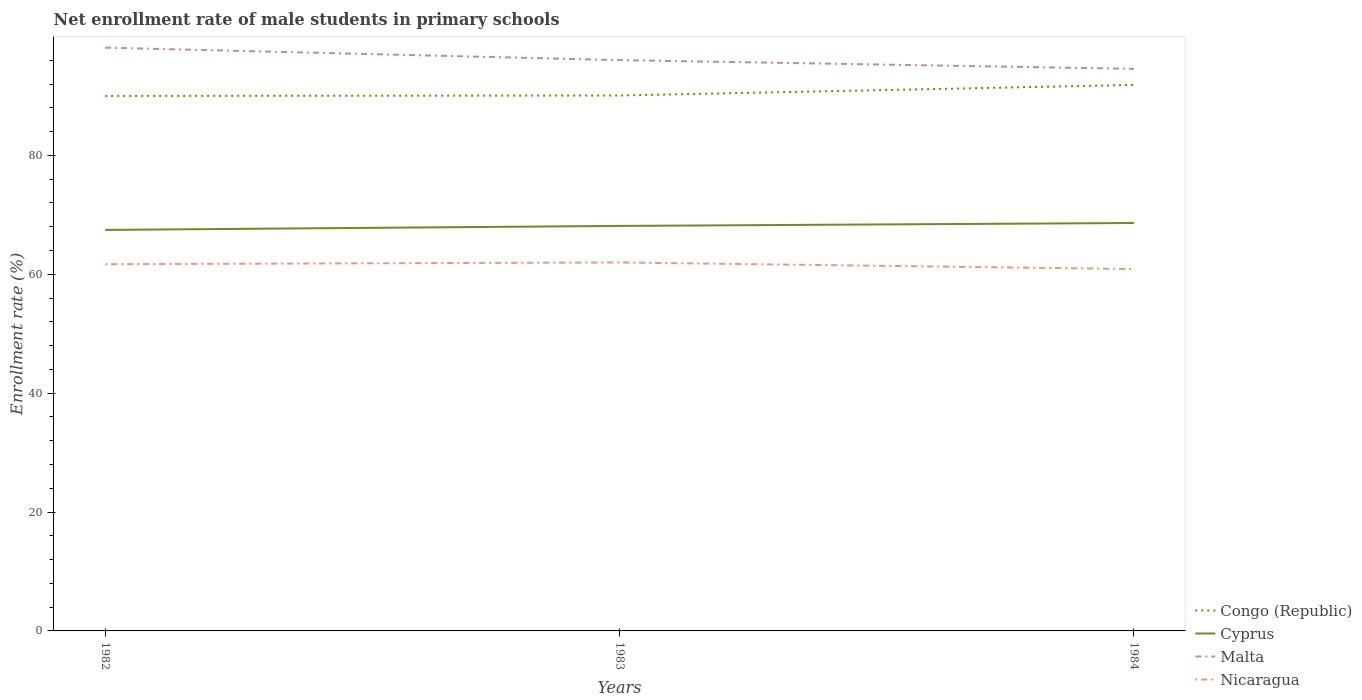How many different coloured lines are there?
Offer a very short reply. 4. Does the line corresponding to Nicaragua intersect with the line corresponding to Cyprus?
Keep it short and to the point. No. Is the number of lines equal to the number of legend labels?
Offer a very short reply. Yes. Across all years, what is the maximum net enrollment rate of male students in primary schools in Congo (Republic)?
Your answer should be compact. 90. What is the total net enrollment rate of male students in primary schools in Nicaragua in the graph?
Offer a terse response. -0.29. What is the difference between the highest and the second highest net enrollment rate of male students in primary schools in Cyprus?
Provide a short and direct response. 1.16. What is the difference between the highest and the lowest net enrollment rate of male students in primary schools in Congo (Republic)?
Keep it short and to the point. 1. How many years are there in the graph?
Make the answer very short. 3. Does the graph contain any zero values?
Your answer should be compact. No. Where does the legend appear in the graph?
Provide a succinct answer. Bottom right. How many legend labels are there?
Provide a succinct answer. 4. What is the title of the graph?
Your answer should be very brief. Net enrollment rate of male students in primary schools. Does "Comoros" appear as one of the legend labels in the graph?
Give a very brief answer. No. What is the label or title of the X-axis?
Ensure brevity in your answer.  Years. What is the label or title of the Y-axis?
Offer a very short reply. Enrollment rate (%). What is the Enrollment rate (%) in Congo (Republic) in 1982?
Your answer should be very brief. 90. What is the Enrollment rate (%) of Cyprus in 1982?
Provide a succinct answer. 67.47. What is the Enrollment rate (%) in Malta in 1982?
Ensure brevity in your answer.  98.13. What is the Enrollment rate (%) in Nicaragua in 1982?
Make the answer very short. 61.7. What is the Enrollment rate (%) in Congo (Republic) in 1983?
Offer a terse response. 90.08. What is the Enrollment rate (%) in Cyprus in 1983?
Offer a terse response. 68.14. What is the Enrollment rate (%) in Malta in 1983?
Make the answer very short. 96.04. What is the Enrollment rate (%) of Nicaragua in 1983?
Keep it short and to the point. 61.99. What is the Enrollment rate (%) of Congo (Republic) in 1984?
Provide a succinct answer. 91.86. What is the Enrollment rate (%) of Cyprus in 1984?
Provide a short and direct response. 68.63. What is the Enrollment rate (%) in Malta in 1984?
Offer a very short reply. 94.57. What is the Enrollment rate (%) of Nicaragua in 1984?
Ensure brevity in your answer.  60.88. Across all years, what is the maximum Enrollment rate (%) in Congo (Republic)?
Keep it short and to the point. 91.86. Across all years, what is the maximum Enrollment rate (%) in Cyprus?
Provide a short and direct response. 68.63. Across all years, what is the maximum Enrollment rate (%) in Malta?
Make the answer very short. 98.13. Across all years, what is the maximum Enrollment rate (%) of Nicaragua?
Provide a succinct answer. 61.99. Across all years, what is the minimum Enrollment rate (%) of Congo (Republic)?
Give a very brief answer. 90. Across all years, what is the minimum Enrollment rate (%) of Cyprus?
Your response must be concise. 67.47. Across all years, what is the minimum Enrollment rate (%) of Malta?
Your answer should be compact. 94.57. Across all years, what is the minimum Enrollment rate (%) of Nicaragua?
Make the answer very short. 60.88. What is the total Enrollment rate (%) of Congo (Republic) in the graph?
Your response must be concise. 271.95. What is the total Enrollment rate (%) of Cyprus in the graph?
Keep it short and to the point. 204.24. What is the total Enrollment rate (%) in Malta in the graph?
Provide a short and direct response. 288.74. What is the total Enrollment rate (%) in Nicaragua in the graph?
Offer a terse response. 184.58. What is the difference between the Enrollment rate (%) of Congo (Republic) in 1982 and that in 1983?
Your answer should be very brief. -0.08. What is the difference between the Enrollment rate (%) of Cyprus in 1982 and that in 1983?
Your answer should be compact. -0.67. What is the difference between the Enrollment rate (%) of Malta in 1982 and that in 1983?
Ensure brevity in your answer.  2.1. What is the difference between the Enrollment rate (%) in Nicaragua in 1982 and that in 1983?
Provide a short and direct response. -0.29. What is the difference between the Enrollment rate (%) of Congo (Republic) in 1982 and that in 1984?
Keep it short and to the point. -1.86. What is the difference between the Enrollment rate (%) in Cyprus in 1982 and that in 1984?
Offer a terse response. -1.16. What is the difference between the Enrollment rate (%) in Malta in 1982 and that in 1984?
Keep it short and to the point. 3.57. What is the difference between the Enrollment rate (%) of Nicaragua in 1982 and that in 1984?
Offer a terse response. 0.82. What is the difference between the Enrollment rate (%) in Congo (Republic) in 1983 and that in 1984?
Ensure brevity in your answer.  -1.78. What is the difference between the Enrollment rate (%) of Cyprus in 1983 and that in 1984?
Offer a terse response. -0.49. What is the difference between the Enrollment rate (%) of Malta in 1983 and that in 1984?
Your response must be concise. 1.47. What is the difference between the Enrollment rate (%) of Nicaragua in 1983 and that in 1984?
Your answer should be compact. 1.11. What is the difference between the Enrollment rate (%) in Congo (Republic) in 1982 and the Enrollment rate (%) in Cyprus in 1983?
Ensure brevity in your answer.  21.86. What is the difference between the Enrollment rate (%) of Congo (Republic) in 1982 and the Enrollment rate (%) of Malta in 1983?
Provide a succinct answer. -6.03. What is the difference between the Enrollment rate (%) of Congo (Republic) in 1982 and the Enrollment rate (%) of Nicaragua in 1983?
Offer a very short reply. 28.01. What is the difference between the Enrollment rate (%) in Cyprus in 1982 and the Enrollment rate (%) in Malta in 1983?
Provide a succinct answer. -28.57. What is the difference between the Enrollment rate (%) in Cyprus in 1982 and the Enrollment rate (%) in Nicaragua in 1983?
Offer a terse response. 5.48. What is the difference between the Enrollment rate (%) in Malta in 1982 and the Enrollment rate (%) in Nicaragua in 1983?
Offer a terse response. 36.14. What is the difference between the Enrollment rate (%) of Congo (Republic) in 1982 and the Enrollment rate (%) of Cyprus in 1984?
Offer a very short reply. 21.37. What is the difference between the Enrollment rate (%) of Congo (Republic) in 1982 and the Enrollment rate (%) of Malta in 1984?
Your response must be concise. -4.56. What is the difference between the Enrollment rate (%) in Congo (Republic) in 1982 and the Enrollment rate (%) in Nicaragua in 1984?
Make the answer very short. 29.12. What is the difference between the Enrollment rate (%) in Cyprus in 1982 and the Enrollment rate (%) in Malta in 1984?
Your response must be concise. -27.1. What is the difference between the Enrollment rate (%) of Cyprus in 1982 and the Enrollment rate (%) of Nicaragua in 1984?
Keep it short and to the point. 6.58. What is the difference between the Enrollment rate (%) in Malta in 1982 and the Enrollment rate (%) in Nicaragua in 1984?
Make the answer very short. 37.25. What is the difference between the Enrollment rate (%) in Congo (Republic) in 1983 and the Enrollment rate (%) in Cyprus in 1984?
Your answer should be very brief. 21.45. What is the difference between the Enrollment rate (%) of Congo (Republic) in 1983 and the Enrollment rate (%) of Malta in 1984?
Keep it short and to the point. -4.49. What is the difference between the Enrollment rate (%) in Congo (Republic) in 1983 and the Enrollment rate (%) in Nicaragua in 1984?
Provide a short and direct response. 29.2. What is the difference between the Enrollment rate (%) of Cyprus in 1983 and the Enrollment rate (%) of Malta in 1984?
Offer a terse response. -26.43. What is the difference between the Enrollment rate (%) in Cyprus in 1983 and the Enrollment rate (%) in Nicaragua in 1984?
Make the answer very short. 7.25. What is the difference between the Enrollment rate (%) in Malta in 1983 and the Enrollment rate (%) in Nicaragua in 1984?
Offer a very short reply. 35.15. What is the average Enrollment rate (%) of Congo (Republic) per year?
Ensure brevity in your answer.  90.65. What is the average Enrollment rate (%) in Cyprus per year?
Offer a very short reply. 68.08. What is the average Enrollment rate (%) of Malta per year?
Offer a terse response. 96.25. What is the average Enrollment rate (%) of Nicaragua per year?
Provide a succinct answer. 61.53. In the year 1982, what is the difference between the Enrollment rate (%) of Congo (Republic) and Enrollment rate (%) of Cyprus?
Your answer should be compact. 22.53. In the year 1982, what is the difference between the Enrollment rate (%) of Congo (Republic) and Enrollment rate (%) of Malta?
Your response must be concise. -8.13. In the year 1982, what is the difference between the Enrollment rate (%) in Congo (Republic) and Enrollment rate (%) in Nicaragua?
Give a very brief answer. 28.3. In the year 1982, what is the difference between the Enrollment rate (%) of Cyprus and Enrollment rate (%) of Malta?
Offer a terse response. -30.66. In the year 1982, what is the difference between the Enrollment rate (%) in Cyprus and Enrollment rate (%) in Nicaragua?
Provide a short and direct response. 5.77. In the year 1982, what is the difference between the Enrollment rate (%) of Malta and Enrollment rate (%) of Nicaragua?
Offer a terse response. 36.43. In the year 1983, what is the difference between the Enrollment rate (%) of Congo (Republic) and Enrollment rate (%) of Cyprus?
Provide a succinct answer. 21.94. In the year 1983, what is the difference between the Enrollment rate (%) in Congo (Republic) and Enrollment rate (%) in Malta?
Give a very brief answer. -5.95. In the year 1983, what is the difference between the Enrollment rate (%) of Congo (Republic) and Enrollment rate (%) of Nicaragua?
Offer a terse response. 28.09. In the year 1983, what is the difference between the Enrollment rate (%) in Cyprus and Enrollment rate (%) in Malta?
Provide a short and direct response. -27.9. In the year 1983, what is the difference between the Enrollment rate (%) in Cyprus and Enrollment rate (%) in Nicaragua?
Your response must be concise. 6.15. In the year 1983, what is the difference between the Enrollment rate (%) of Malta and Enrollment rate (%) of Nicaragua?
Provide a succinct answer. 34.04. In the year 1984, what is the difference between the Enrollment rate (%) of Congo (Republic) and Enrollment rate (%) of Cyprus?
Your response must be concise. 23.23. In the year 1984, what is the difference between the Enrollment rate (%) in Congo (Republic) and Enrollment rate (%) in Malta?
Your answer should be compact. -2.7. In the year 1984, what is the difference between the Enrollment rate (%) in Congo (Republic) and Enrollment rate (%) in Nicaragua?
Offer a terse response. 30.98. In the year 1984, what is the difference between the Enrollment rate (%) in Cyprus and Enrollment rate (%) in Malta?
Give a very brief answer. -25.94. In the year 1984, what is the difference between the Enrollment rate (%) in Cyprus and Enrollment rate (%) in Nicaragua?
Your answer should be very brief. 7.75. In the year 1984, what is the difference between the Enrollment rate (%) in Malta and Enrollment rate (%) in Nicaragua?
Keep it short and to the point. 33.68. What is the ratio of the Enrollment rate (%) in Congo (Republic) in 1982 to that in 1983?
Offer a very short reply. 1. What is the ratio of the Enrollment rate (%) in Cyprus in 1982 to that in 1983?
Provide a succinct answer. 0.99. What is the ratio of the Enrollment rate (%) of Malta in 1982 to that in 1983?
Your answer should be compact. 1.02. What is the ratio of the Enrollment rate (%) of Nicaragua in 1982 to that in 1983?
Offer a terse response. 1. What is the ratio of the Enrollment rate (%) of Congo (Republic) in 1982 to that in 1984?
Your response must be concise. 0.98. What is the ratio of the Enrollment rate (%) in Malta in 1982 to that in 1984?
Make the answer very short. 1.04. What is the ratio of the Enrollment rate (%) in Nicaragua in 1982 to that in 1984?
Provide a succinct answer. 1.01. What is the ratio of the Enrollment rate (%) in Congo (Republic) in 1983 to that in 1984?
Your answer should be very brief. 0.98. What is the ratio of the Enrollment rate (%) of Cyprus in 1983 to that in 1984?
Keep it short and to the point. 0.99. What is the ratio of the Enrollment rate (%) of Malta in 1983 to that in 1984?
Keep it short and to the point. 1.02. What is the ratio of the Enrollment rate (%) of Nicaragua in 1983 to that in 1984?
Provide a succinct answer. 1.02. What is the difference between the highest and the second highest Enrollment rate (%) in Congo (Republic)?
Your answer should be very brief. 1.78. What is the difference between the highest and the second highest Enrollment rate (%) in Cyprus?
Give a very brief answer. 0.49. What is the difference between the highest and the second highest Enrollment rate (%) in Malta?
Keep it short and to the point. 2.1. What is the difference between the highest and the second highest Enrollment rate (%) in Nicaragua?
Provide a short and direct response. 0.29. What is the difference between the highest and the lowest Enrollment rate (%) in Congo (Republic)?
Offer a terse response. 1.86. What is the difference between the highest and the lowest Enrollment rate (%) in Cyprus?
Make the answer very short. 1.16. What is the difference between the highest and the lowest Enrollment rate (%) in Malta?
Give a very brief answer. 3.57. What is the difference between the highest and the lowest Enrollment rate (%) of Nicaragua?
Offer a very short reply. 1.11. 